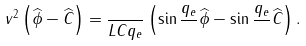Convert formula to latex. <formula><loc_0><loc_0><loc_500><loc_500>v ^ { 2 } \left ( \widehat { \phi } - \widehat { C } \right ) = \frac { } { L C q _ { e } } \left ( \sin \frac { q _ { e } } { } \widehat { \phi } - \sin \frac { q _ { e } } { } \widehat { C } \right ) .</formula> 